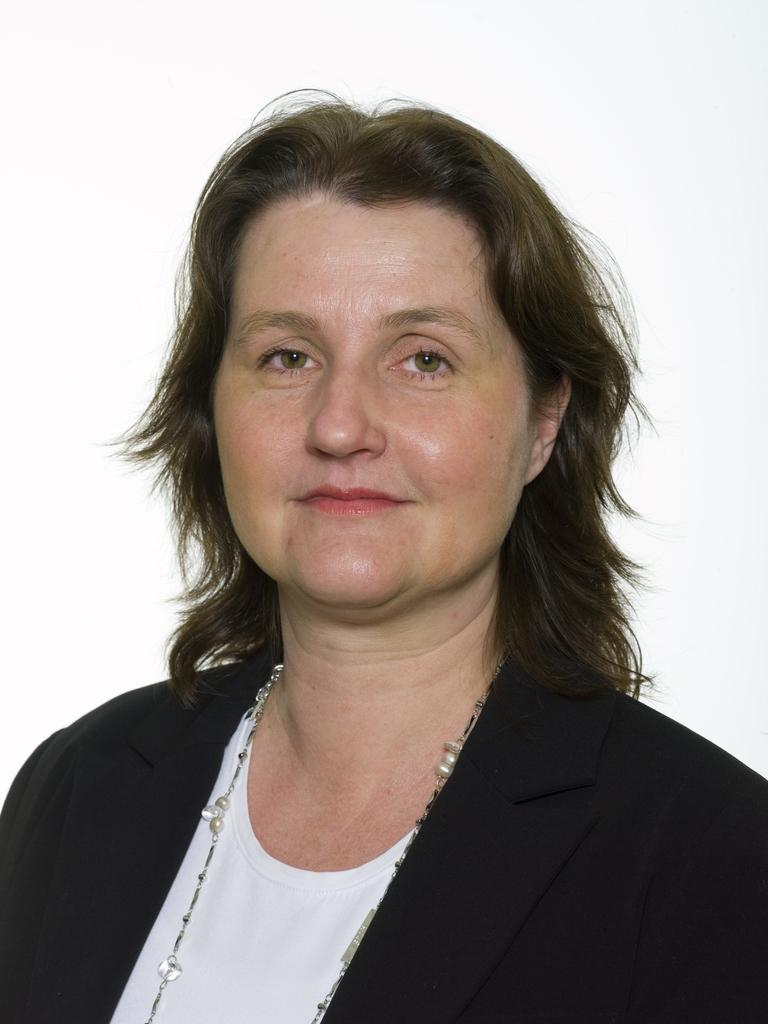What is the main subject of the image? There is a woman standing in the center of the image. How does the woman appear to be feeling in the image? The woman is smiling, which suggests she is happy or content. Can you describe the woman's facial expression in the image? The woman's facial expression shows her smiling. How many people are in the crowd surrounding the woman in the image? There is no crowd present in the image; it features a single woman standing in the center. What type of respect is being shown to the woman in the image? There is no indication of respect being shown to the woman in the image, as it only depicts her standing and smiling. 